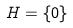Convert formula to latex. <formula><loc_0><loc_0><loc_500><loc_500>H = \{ 0 \}</formula> 